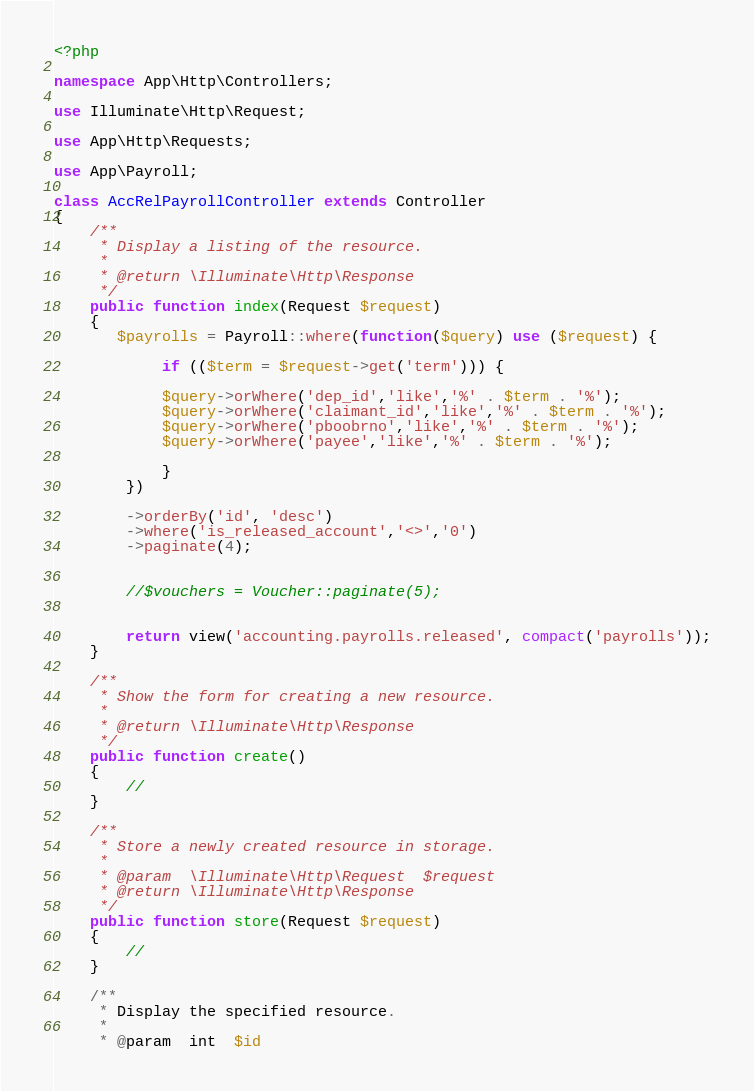<code> <loc_0><loc_0><loc_500><loc_500><_PHP_><?php

namespace App\Http\Controllers;

use Illuminate\Http\Request;

use App\Http\Requests;

use App\Payroll;

class AccRelPayrollController extends Controller
{
    /**
     * Display a listing of the resource.
     *
     * @return \Illuminate\Http\Response
     */
    public function index(Request $request)
    {
       $payrolls = Payroll::where(function($query) use ($request) {
            
            if (($term = $request->get('term'))) {

            $query->orWhere('dep_id','like','%' . $term . '%');
            $query->orWhere('claimant_id','like','%' . $term . '%');
            $query->orWhere('pboobrno','like','%' . $term . '%');
            $query->orWhere('payee','like','%' . $term . '%');

            }
        })
                   
        ->orderBy('id', 'desc')
        ->where('is_released_account','<>','0')
        ->paginate(4);


        //$vouchers = Voucher::paginate(5);

        
        return view('accounting.payrolls.released', compact('payrolls'));
    }

    /**
     * Show the form for creating a new resource.
     *
     * @return \Illuminate\Http\Response
     */
    public function create()
    {
        //
    }

    /**
     * Store a newly created resource in storage.
     *
     * @param  \Illuminate\Http\Request  $request
     * @return \Illuminate\Http\Response
     */
    public function store(Request $request)
    {
        //
    }

    /**
     * Display the specified resource.
     *
     * @param  int  $id</code> 